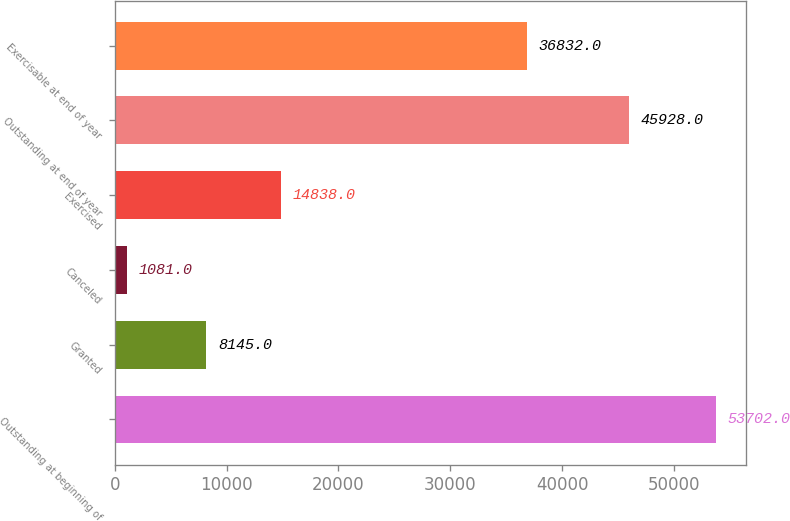<chart> <loc_0><loc_0><loc_500><loc_500><bar_chart><fcel>Outstanding at beginning of<fcel>Granted<fcel>Canceled<fcel>Exercised<fcel>Outstanding at end of year<fcel>Exercisable at end of year<nl><fcel>53702<fcel>8145<fcel>1081<fcel>14838<fcel>45928<fcel>36832<nl></chart> 